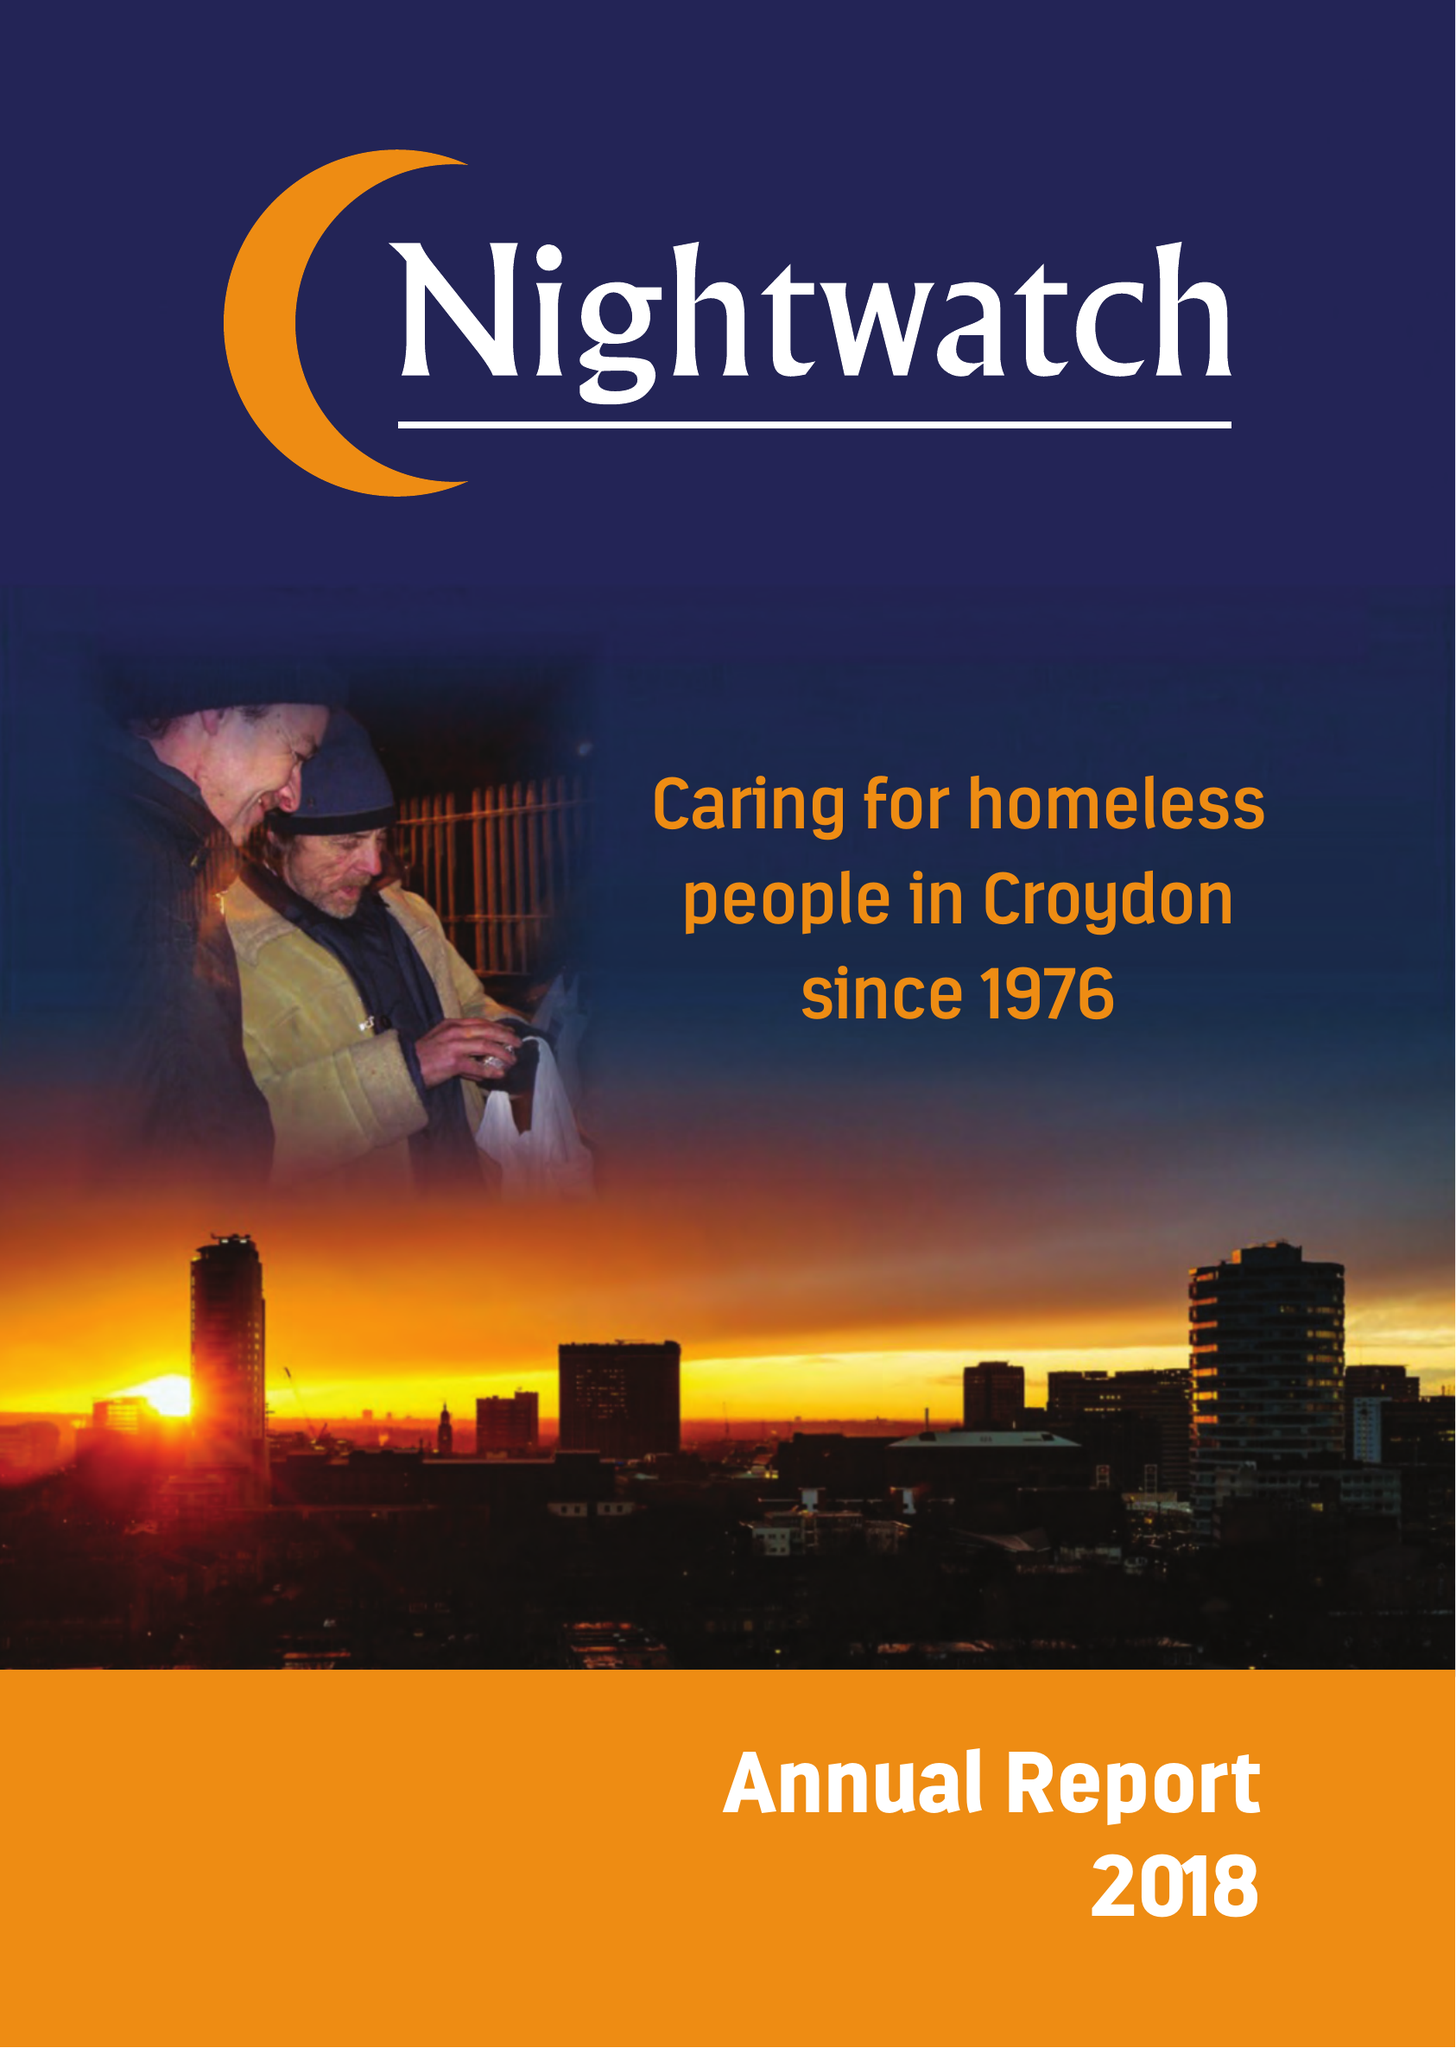What is the value for the address__post_town?
Answer the question using a single word or phrase. LONDON 